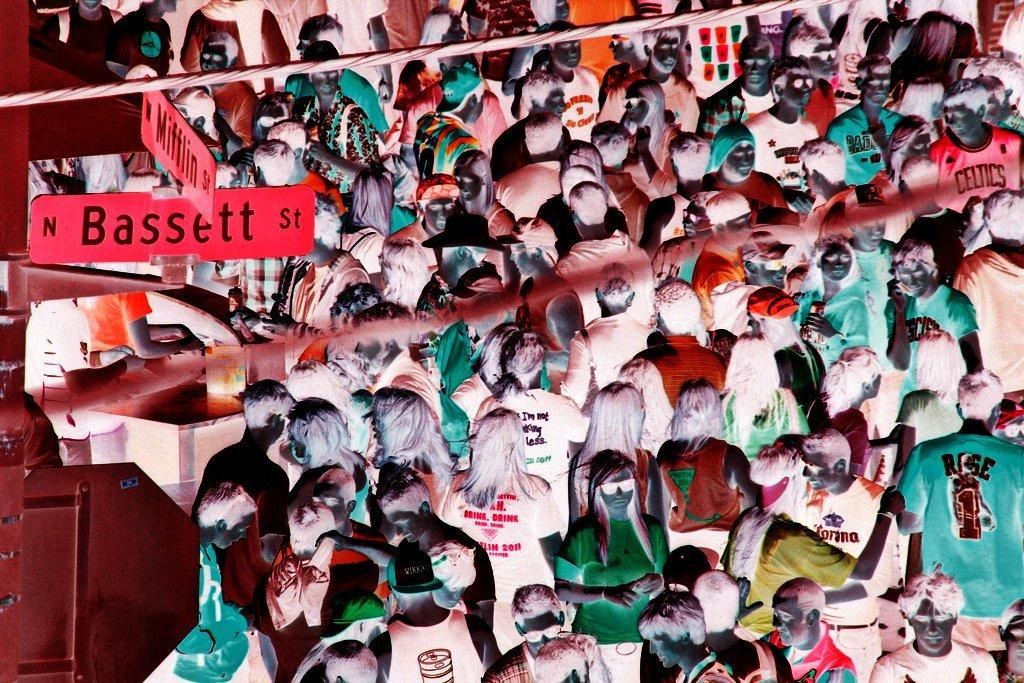<image>
Render a clear and concise summary of the photo. A large crowd gathers at the corner of North Bassett Street. 